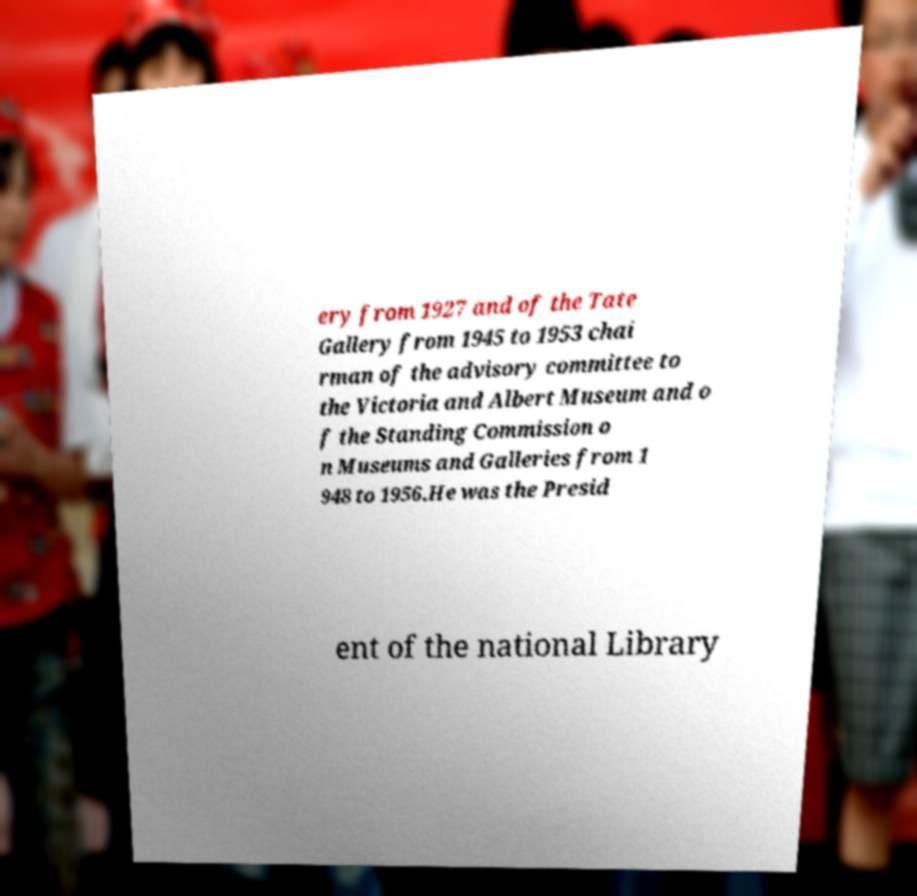There's text embedded in this image that I need extracted. Can you transcribe it verbatim? ery from 1927 and of the Tate Gallery from 1945 to 1953 chai rman of the advisory committee to the Victoria and Albert Museum and o f the Standing Commission o n Museums and Galleries from 1 948 to 1956.He was the Presid ent of the national Library 